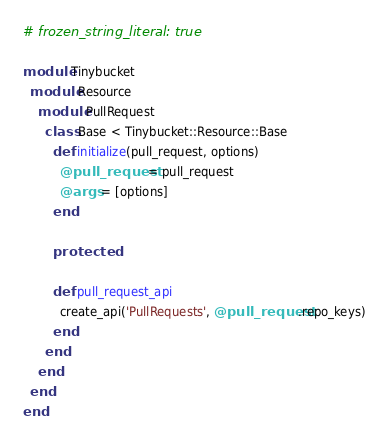Convert code to text. <code><loc_0><loc_0><loc_500><loc_500><_Ruby_># frozen_string_literal: true

module Tinybucket
  module Resource
    module PullRequest
      class Base < Tinybucket::Resource::Base
        def initialize(pull_request, options)
          @pull_request = pull_request
          @args = [options]
        end

        protected

        def pull_request_api
          create_api('PullRequests', @pull_request.repo_keys)
        end
      end
    end
  end
end
</code> 